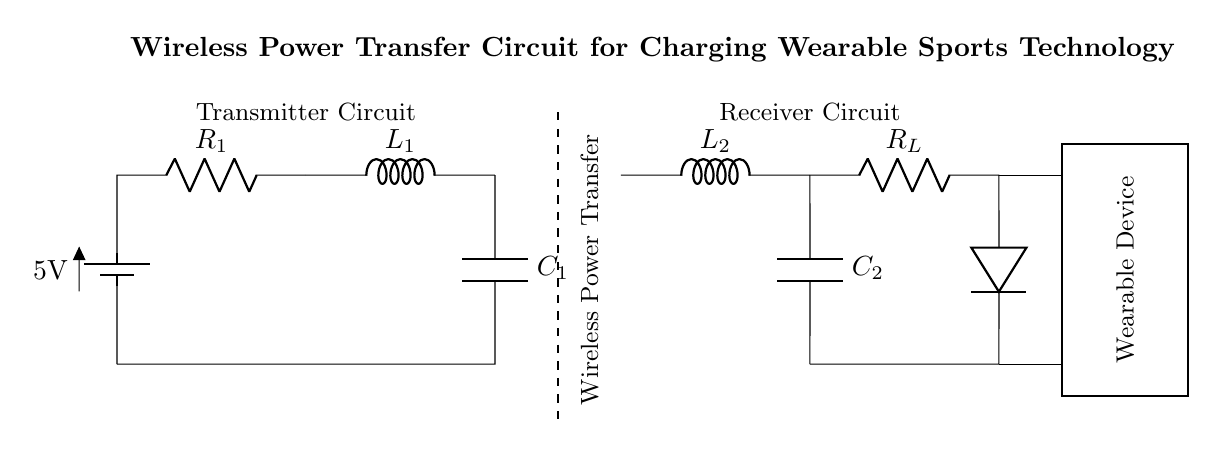What is the voltage of the battery? The voltage is indicated as 5V on the battery symbol. This represents the potential difference supplied by the battery in the circuit.
Answer: 5V What are the components in the transmitter circuit? The transmitter circuit consists of a battery, a resistor (R1), an inductor (L1), and a capacitor (C1). Each component is connected in series to facilitate the wireless power transfer.
Answer: Battery, resistor, inductor, capacitor How many inductors are present in the circuit? There are two inductors in the circuit: L1 in the transmitter and L2 in the receiver side. Each plays a role in creating the electromagnetic field required for wireless power transfer.
Answer: Two What is the function of the diode in the receiver circuit? The diode is used for rectification; it allows current to flow in one direction only, which is essential for converting the AC signal obtained from the coils into DC current suitable for charging the wearable device.
Answer: Rectification What type of circuit is this an example of? This circuit is an example of a wireless power transfer circuit designed specifically for charging low power appliances like wearable sports technology. This type of circuit utilizes inductive coupling for energy transfer.
Answer: Wireless power transfer circuit 